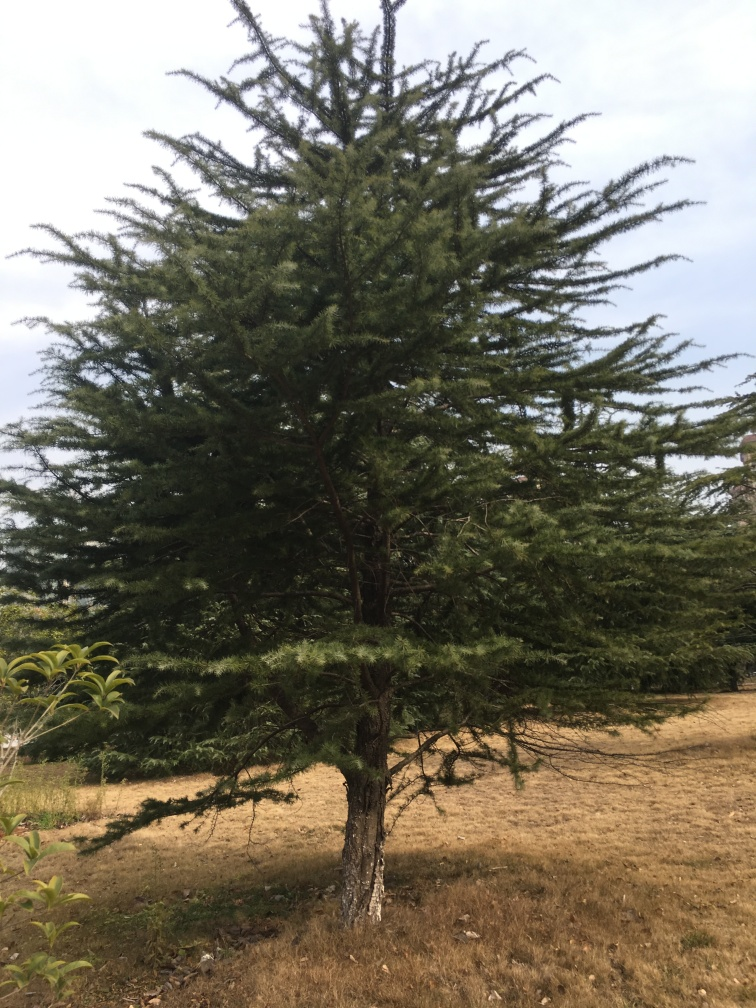What species of tree is this? This appears to be a coniferous tree, possibly a type of fir or spruce, characterized by its needle-like leaves and cone-shaped growth. The exact species would require closer examination or a more specific context. 